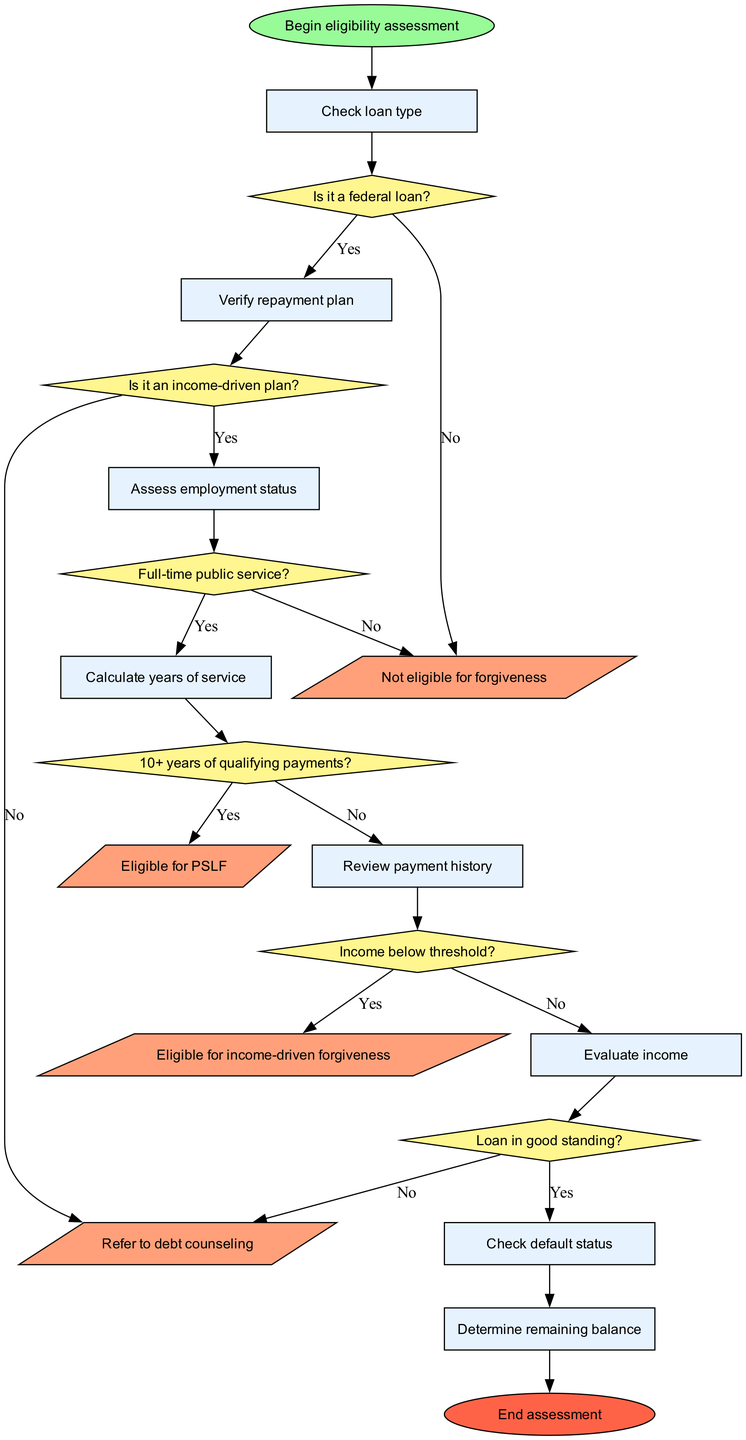What is the starting point of this assessment? The diagram indicates that the starting point of the assessment is labeled as "Begin eligibility assessment," which is represented by the shape of an ellipse in the diagram.
Answer: Begin eligibility assessment How many decision nodes are there in the diagram? The diagram lists six decision nodes, starting from "Is it a federal loan?" up to "Loan in good standing?". Each decision is represented by a diamond shape.
Answer: 6 What outcome results from having 10 or more years of qualifying payments? The diagram shows that if the condition of having 10 or more years of qualifying payments is satisfied, the result is "Eligible for PSLF," which is indicated as an outcome node in the diagram.
Answer: Eligible for PSLF What is the relationship between the "Verify repayment plan" node and the decision "Is it an income-driven plan?" The relationship is sequential; after "Verify repayment plan," the flow goes to the decision node "Is it an income-driven plan?" thus indicating that it is the next step in the process flow following that verification.
Answer: Sequential If a loan is not in good standing, what does the flow indicate as the next step? The flow indicates that if the loan is not in good standing (answering "No" at the "Loan in good standing?" decision node), it leads to the outcome "Not eligible for forgiveness." This indicates that bad loan standing directly affects eligibility for forgiveness.
Answer: Not eligible for forgiveness What happens if the individual does not have a federal loan? According to the flowchart, if the individual does not have a federal loan (when answering "No" at the "Is it a federal loan?" decision node), the assessment leads to the outcome "Not eligible for forgiveness." This outcome is a direct consequence of lacking federal loan status.
Answer: Not eligible for forgiveness How is the "Review payment history" node connected to the assessment process? The "Review payment history" node follows the "Calculate years of service" node and directly connects to the decision "10+ years of qualifying payments?" indicating that it is a step in the assessment process that influences later decisions regarding eligibility.
Answer: Step in the process What does the diagram show about individuals earning above the income threshold? The diagram indicates that if individuals have an income above the threshold (answering "No" at the "Income below threshold?" decision node), they would fall into the outcome "Not eligible for forgiveness," implying a direct correlation between higher income and ineligibility.
Answer: Not eligible for forgiveness 